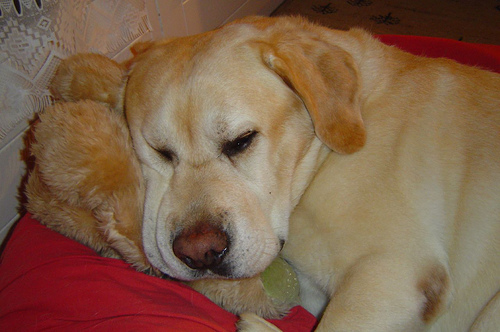This dog seems to be resting; can you tell me more about its environment? Certainly, the dog is lying on a vibrant red pillow, suggesting a home environment. The presence of a tennis ball indicates the dog may have been playing before deciding to take a break for a nap.  Does the dog seem to have a favorite toy? While I cannot know for sure, the tennis ball located close to the dog might be its favorite toy, as many dogs have a penchant for playing fetch with balls. 